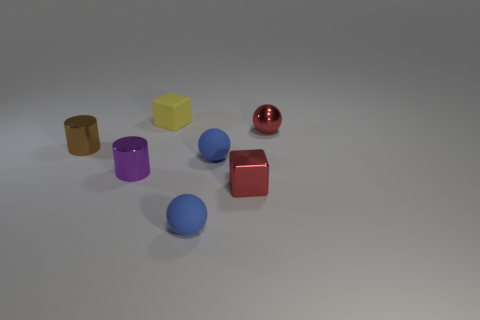What is the color of the cube behind the block in front of the thing that is behind the red ball?
Keep it short and to the point. Yellow. What is the shape of the rubber thing that is both in front of the matte block and behind the small metallic block?
Your answer should be very brief. Sphere. What color is the shiny thing that is right of the red object in front of the purple metal cylinder?
Your answer should be compact. Red. There is a blue matte thing to the right of the matte object in front of the red metallic object in front of the brown cylinder; what is its shape?
Provide a short and direct response. Sphere. There is a ball that is behind the red shiny block and on the left side of the small red cube; what size is it?
Provide a succinct answer. Small. What number of small things are the same color as the small metal block?
Make the answer very short. 1. What material is the purple object?
Keep it short and to the point. Metal. Is the material of the small blue ball that is behind the tiny metal cube the same as the tiny yellow thing?
Keep it short and to the point. Yes. What is the shape of the small thing behind the metallic sphere?
Your response must be concise. Cube. There is a brown object that is the same size as the purple metallic thing; what is its material?
Your response must be concise. Metal. 